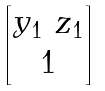<formula> <loc_0><loc_0><loc_500><loc_500>\begin{bmatrix} y _ { 1 } \ z _ { 1 } \\ 1 \end{bmatrix}</formula> 